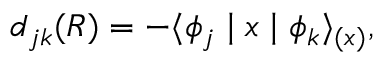<formula> <loc_0><loc_0><loc_500><loc_500>d _ { j k } ( R ) = - \langle \phi _ { j } | x | \phi _ { k } \rangle _ { ( x ) } ,</formula> 